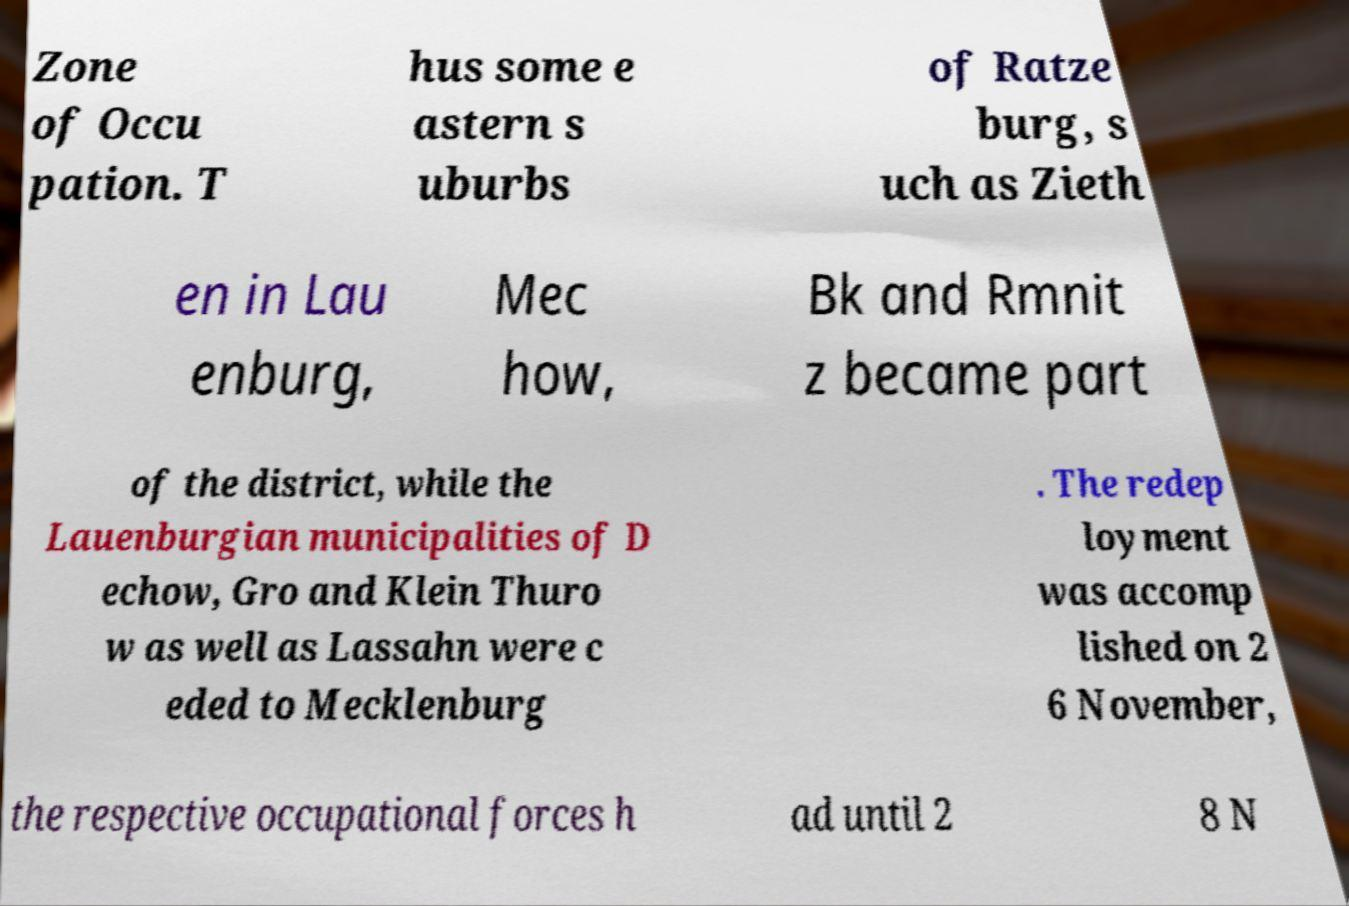For documentation purposes, I need the text within this image transcribed. Could you provide that? Zone of Occu pation. T hus some e astern s uburbs of Ratze burg, s uch as Zieth en in Lau enburg, Mec how, Bk and Rmnit z became part of the district, while the Lauenburgian municipalities of D echow, Gro and Klein Thuro w as well as Lassahn were c eded to Mecklenburg . The redep loyment was accomp lished on 2 6 November, the respective occupational forces h ad until 2 8 N 